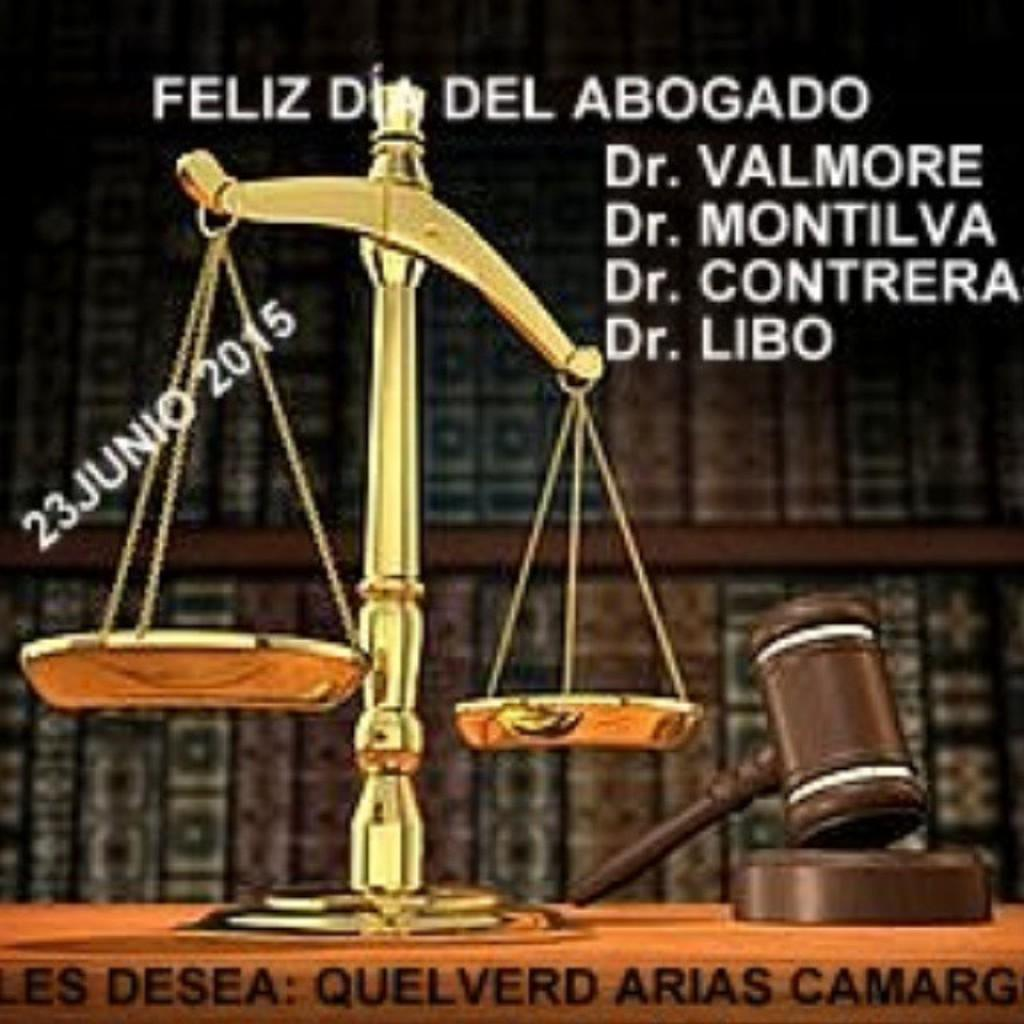What is the main object in the picture? There is a weighing machine in the picture. What other object can be seen in the image? There is a hammer in the picture. What is written around the weighing machine? There are names written around the weighing machine. How has the image been altered? The image has been edited. What can be observed about the background of the weighing machine? The background of the weighing machine is blurred. What type of glove is the laborer wearing in the image? There is no laborer or glove present in the image. How old is the baby in the image? There is no baby present in the image. 